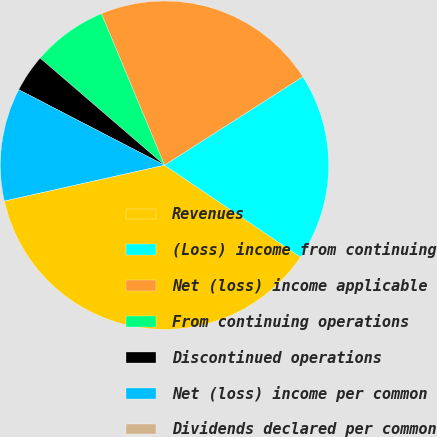Convert chart. <chart><loc_0><loc_0><loc_500><loc_500><pie_chart><fcel>Revenues<fcel>(Loss) income from continuing<fcel>Net (loss) income applicable<fcel>From continuing operations<fcel>Discontinued operations<fcel>Net (loss) income per common<fcel>Dividends declared per common<nl><fcel>37.03%<fcel>18.52%<fcel>22.22%<fcel>7.41%<fcel>3.71%<fcel>11.11%<fcel>0.0%<nl></chart> 